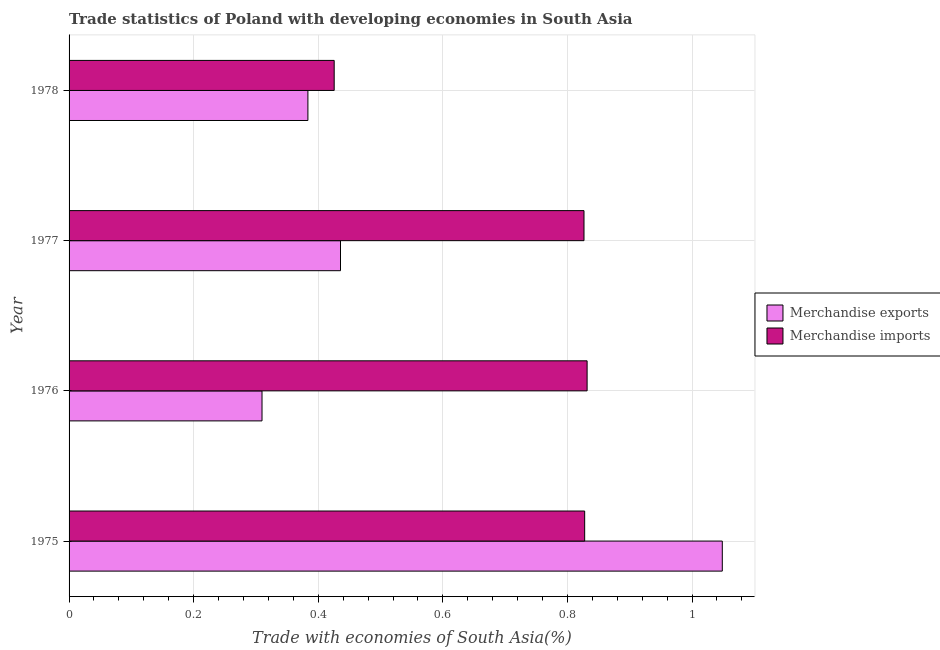Are the number of bars per tick equal to the number of legend labels?
Offer a very short reply. Yes. Are the number of bars on each tick of the Y-axis equal?
Offer a terse response. Yes. How many bars are there on the 2nd tick from the top?
Offer a very short reply. 2. How many bars are there on the 2nd tick from the bottom?
Your answer should be very brief. 2. What is the label of the 4th group of bars from the top?
Your answer should be compact. 1975. In how many cases, is the number of bars for a given year not equal to the number of legend labels?
Ensure brevity in your answer.  0. What is the merchandise imports in 1975?
Your answer should be compact. 0.83. Across all years, what is the maximum merchandise exports?
Your answer should be compact. 1.05. Across all years, what is the minimum merchandise exports?
Keep it short and to the point. 0.31. In which year was the merchandise imports maximum?
Offer a terse response. 1976. In which year was the merchandise imports minimum?
Offer a very short reply. 1978. What is the total merchandise imports in the graph?
Your response must be concise. 2.91. What is the difference between the merchandise exports in 1975 and that in 1978?
Your answer should be very brief. 0.67. What is the difference between the merchandise imports in 1977 and the merchandise exports in 1978?
Make the answer very short. 0.44. What is the average merchandise imports per year?
Ensure brevity in your answer.  0.73. In the year 1975, what is the difference between the merchandise exports and merchandise imports?
Ensure brevity in your answer.  0.22. In how many years, is the merchandise exports greater than 0.24000000000000002 %?
Offer a very short reply. 4. What is the ratio of the merchandise imports in 1977 to that in 1978?
Your response must be concise. 1.94. Is the merchandise imports in 1977 less than that in 1978?
Your answer should be very brief. No. What is the difference between the highest and the second highest merchandise imports?
Ensure brevity in your answer.  0. What is the difference between the highest and the lowest merchandise imports?
Offer a terse response. 0.41. What does the 2nd bar from the bottom in 1978 represents?
Your answer should be compact. Merchandise imports. How many bars are there?
Offer a very short reply. 8. Are all the bars in the graph horizontal?
Provide a short and direct response. Yes. What is the difference between two consecutive major ticks on the X-axis?
Provide a short and direct response. 0.2. Are the values on the major ticks of X-axis written in scientific E-notation?
Offer a very short reply. No. Does the graph contain any zero values?
Your answer should be compact. No. Does the graph contain grids?
Make the answer very short. Yes. How are the legend labels stacked?
Ensure brevity in your answer.  Vertical. What is the title of the graph?
Ensure brevity in your answer.  Trade statistics of Poland with developing economies in South Asia. Does "Female labor force" appear as one of the legend labels in the graph?
Make the answer very short. No. What is the label or title of the X-axis?
Make the answer very short. Trade with economies of South Asia(%). What is the label or title of the Y-axis?
Provide a succinct answer. Year. What is the Trade with economies of South Asia(%) of Merchandise exports in 1975?
Your answer should be very brief. 1.05. What is the Trade with economies of South Asia(%) of Merchandise imports in 1975?
Give a very brief answer. 0.83. What is the Trade with economies of South Asia(%) of Merchandise exports in 1976?
Your answer should be very brief. 0.31. What is the Trade with economies of South Asia(%) in Merchandise imports in 1976?
Provide a succinct answer. 0.83. What is the Trade with economies of South Asia(%) of Merchandise exports in 1977?
Give a very brief answer. 0.44. What is the Trade with economies of South Asia(%) of Merchandise imports in 1977?
Your answer should be very brief. 0.83. What is the Trade with economies of South Asia(%) in Merchandise exports in 1978?
Provide a succinct answer. 0.38. What is the Trade with economies of South Asia(%) of Merchandise imports in 1978?
Your answer should be compact. 0.43. Across all years, what is the maximum Trade with economies of South Asia(%) in Merchandise exports?
Make the answer very short. 1.05. Across all years, what is the maximum Trade with economies of South Asia(%) of Merchandise imports?
Ensure brevity in your answer.  0.83. Across all years, what is the minimum Trade with economies of South Asia(%) in Merchandise exports?
Provide a succinct answer. 0.31. Across all years, what is the minimum Trade with economies of South Asia(%) of Merchandise imports?
Offer a very short reply. 0.43. What is the total Trade with economies of South Asia(%) in Merchandise exports in the graph?
Provide a short and direct response. 2.18. What is the total Trade with economies of South Asia(%) in Merchandise imports in the graph?
Ensure brevity in your answer.  2.91. What is the difference between the Trade with economies of South Asia(%) of Merchandise exports in 1975 and that in 1976?
Your answer should be very brief. 0.74. What is the difference between the Trade with economies of South Asia(%) of Merchandise imports in 1975 and that in 1976?
Offer a terse response. -0. What is the difference between the Trade with economies of South Asia(%) in Merchandise exports in 1975 and that in 1977?
Offer a very short reply. 0.61. What is the difference between the Trade with economies of South Asia(%) in Merchandise imports in 1975 and that in 1977?
Offer a terse response. 0. What is the difference between the Trade with economies of South Asia(%) of Merchandise exports in 1975 and that in 1978?
Offer a very short reply. 0.67. What is the difference between the Trade with economies of South Asia(%) in Merchandise imports in 1975 and that in 1978?
Offer a very short reply. 0.4. What is the difference between the Trade with economies of South Asia(%) of Merchandise exports in 1976 and that in 1977?
Your answer should be compact. -0.13. What is the difference between the Trade with economies of South Asia(%) of Merchandise imports in 1976 and that in 1977?
Offer a very short reply. 0.01. What is the difference between the Trade with economies of South Asia(%) of Merchandise exports in 1976 and that in 1978?
Provide a short and direct response. -0.07. What is the difference between the Trade with economies of South Asia(%) in Merchandise imports in 1976 and that in 1978?
Provide a succinct answer. 0.41. What is the difference between the Trade with economies of South Asia(%) of Merchandise exports in 1977 and that in 1978?
Your answer should be very brief. 0.05. What is the difference between the Trade with economies of South Asia(%) of Merchandise imports in 1977 and that in 1978?
Give a very brief answer. 0.4. What is the difference between the Trade with economies of South Asia(%) in Merchandise exports in 1975 and the Trade with economies of South Asia(%) in Merchandise imports in 1976?
Keep it short and to the point. 0.22. What is the difference between the Trade with economies of South Asia(%) of Merchandise exports in 1975 and the Trade with economies of South Asia(%) of Merchandise imports in 1977?
Your answer should be compact. 0.22. What is the difference between the Trade with economies of South Asia(%) in Merchandise exports in 1975 and the Trade with economies of South Asia(%) in Merchandise imports in 1978?
Give a very brief answer. 0.62. What is the difference between the Trade with economies of South Asia(%) in Merchandise exports in 1976 and the Trade with economies of South Asia(%) in Merchandise imports in 1977?
Keep it short and to the point. -0.52. What is the difference between the Trade with economies of South Asia(%) in Merchandise exports in 1976 and the Trade with economies of South Asia(%) in Merchandise imports in 1978?
Ensure brevity in your answer.  -0.12. What is the difference between the Trade with economies of South Asia(%) of Merchandise exports in 1977 and the Trade with economies of South Asia(%) of Merchandise imports in 1978?
Ensure brevity in your answer.  0.01. What is the average Trade with economies of South Asia(%) in Merchandise exports per year?
Your response must be concise. 0.54. What is the average Trade with economies of South Asia(%) in Merchandise imports per year?
Provide a short and direct response. 0.73. In the year 1975, what is the difference between the Trade with economies of South Asia(%) of Merchandise exports and Trade with economies of South Asia(%) of Merchandise imports?
Your response must be concise. 0.22. In the year 1976, what is the difference between the Trade with economies of South Asia(%) of Merchandise exports and Trade with economies of South Asia(%) of Merchandise imports?
Give a very brief answer. -0.52. In the year 1977, what is the difference between the Trade with economies of South Asia(%) of Merchandise exports and Trade with economies of South Asia(%) of Merchandise imports?
Offer a very short reply. -0.39. In the year 1978, what is the difference between the Trade with economies of South Asia(%) of Merchandise exports and Trade with economies of South Asia(%) of Merchandise imports?
Offer a very short reply. -0.04. What is the ratio of the Trade with economies of South Asia(%) in Merchandise exports in 1975 to that in 1976?
Your answer should be compact. 3.39. What is the ratio of the Trade with economies of South Asia(%) of Merchandise imports in 1975 to that in 1976?
Your response must be concise. 1. What is the ratio of the Trade with economies of South Asia(%) of Merchandise exports in 1975 to that in 1977?
Give a very brief answer. 2.41. What is the ratio of the Trade with economies of South Asia(%) of Merchandise imports in 1975 to that in 1977?
Give a very brief answer. 1. What is the ratio of the Trade with economies of South Asia(%) in Merchandise exports in 1975 to that in 1978?
Your answer should be compact. 2.74. What is the ratio of the Trade with economies of South Asia(%) in Merchandise imports in 1975 to that in 1978?
Your response must be concise. 1.94. What is the ratio of the Trade with economies of South Asia(%) in Merchandise exports in 1976 to that in 1977?
Provide a short and direct response. 0.71. What is the ratio of the Trade with economies of South Asia(%) in Merchandise exports in 1976 to that in 1978?
Provide a succinct answer. 0.81. What is the ratio of the Trade with economies of South Asia(%) of Merchandise imports in 1976 to that in 1978?
Keep it short and to the point. 1.95. What is the ratio of the Trade with economies of South Asia(%) in Merchandise exports in 1977 to that in 1978?
Your response must be concise. 1.14. What is the ratio of the Trade with economies of South Asia(%) in Merchandise imports in 1977 to that in 1978?
Ensure brevity in your answer.  1.94. What is the difference between the highest and the second highest Trade with economies of South Asia(%) of Merchandise exports?
Provide a succinct answer. 0.61. What is the difference between the highest and the second highest Trade with economies of South Asia(%) of Merchandise imports?
Ensure brevity in your answer.  0. What is the difference between the highest and the lowest Trade with economies of South Asia(%) of Merchandise exports?
Offer a very short reply. 0.74. What is the difference between the highest and the lowest Trade with economies of South Asia(%) of Merchandise imports?
Your answer should be compact. 0.41. 